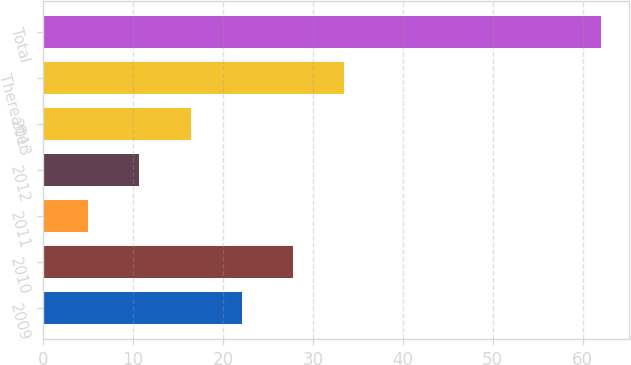Convert chart. <chart><loc_0><loc_0><loc_500><loc_500><bar_chart><fcel>2009<fcel>2010<fcel>2011<fcel>2012<fcel>2013<fcel>Thereafter<fcel>Total<nl><fcel>22.1<fcel>27.8<fcel>5<fcel>10.7<fcel>16.4<fcel>33.5<fcel>62<nl></chart> 